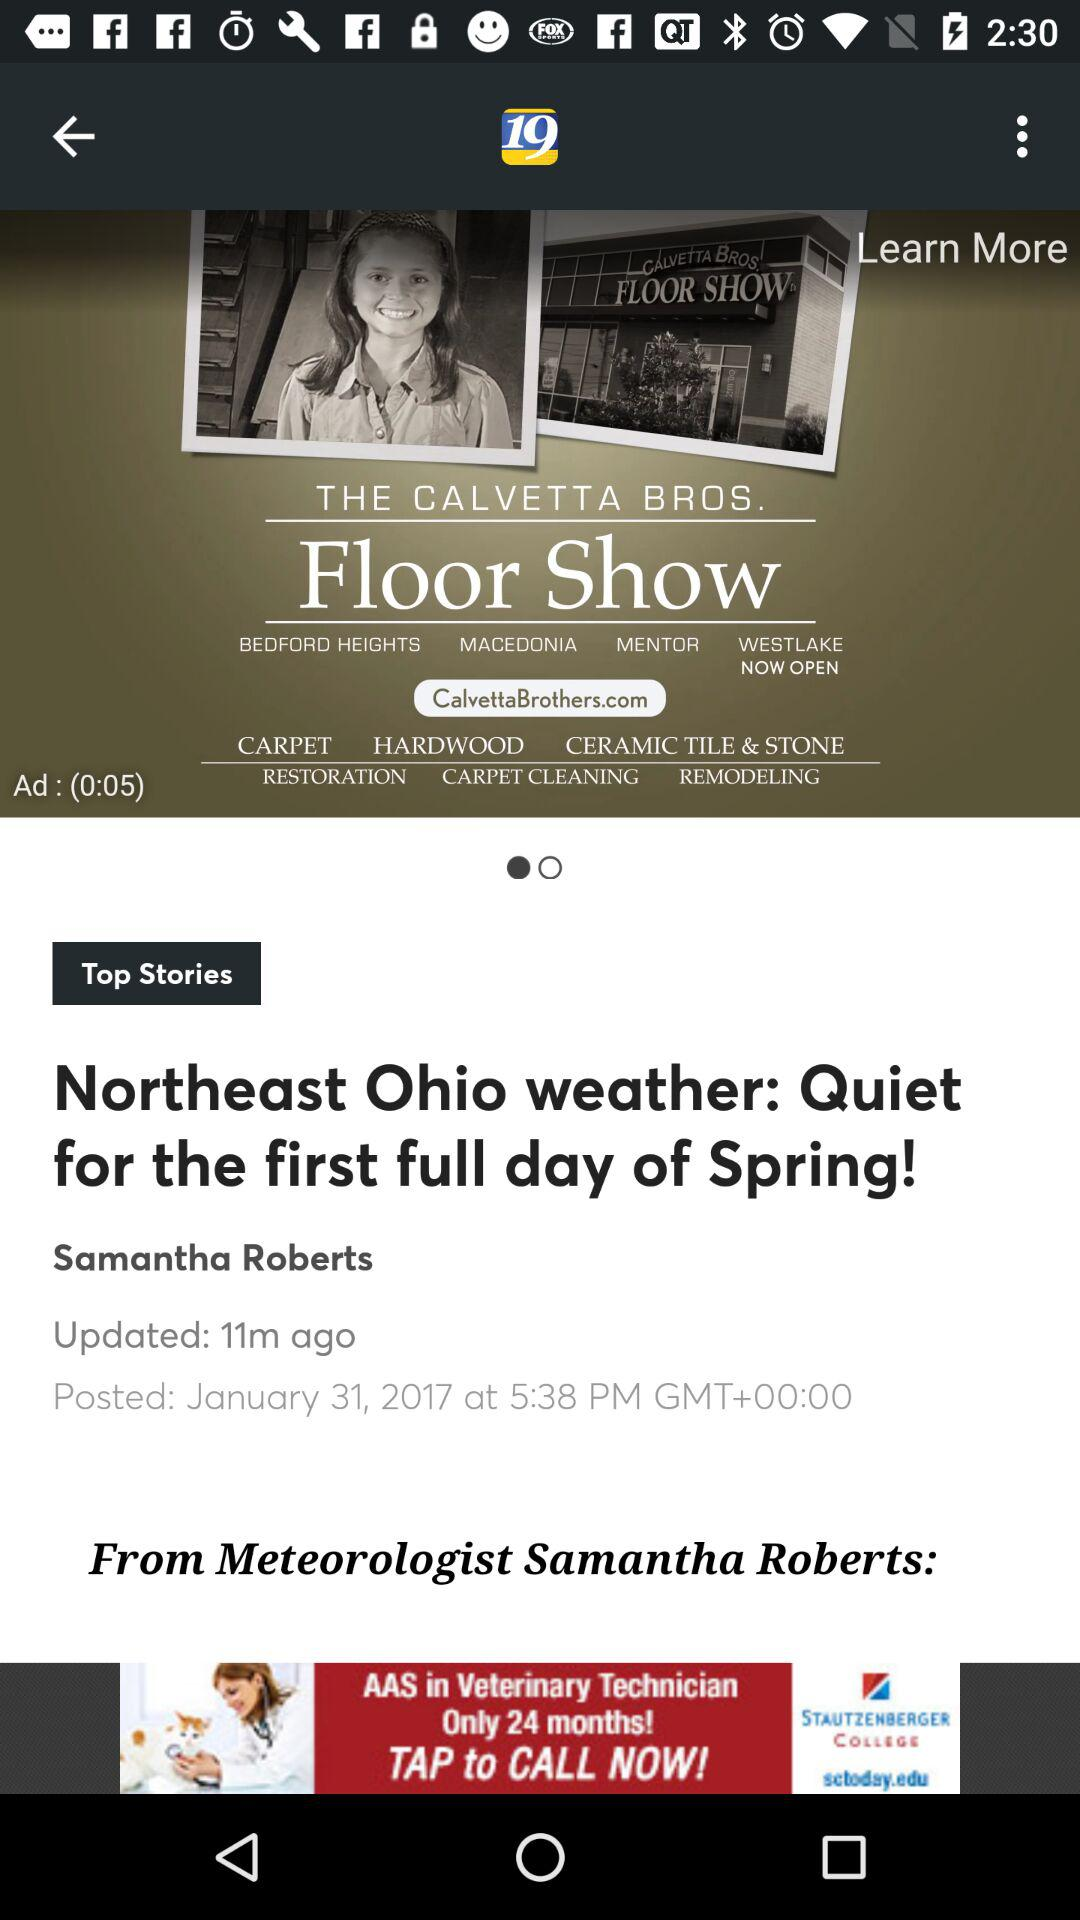Who is the author of the article? The author of the article is Samantha Roberts. 